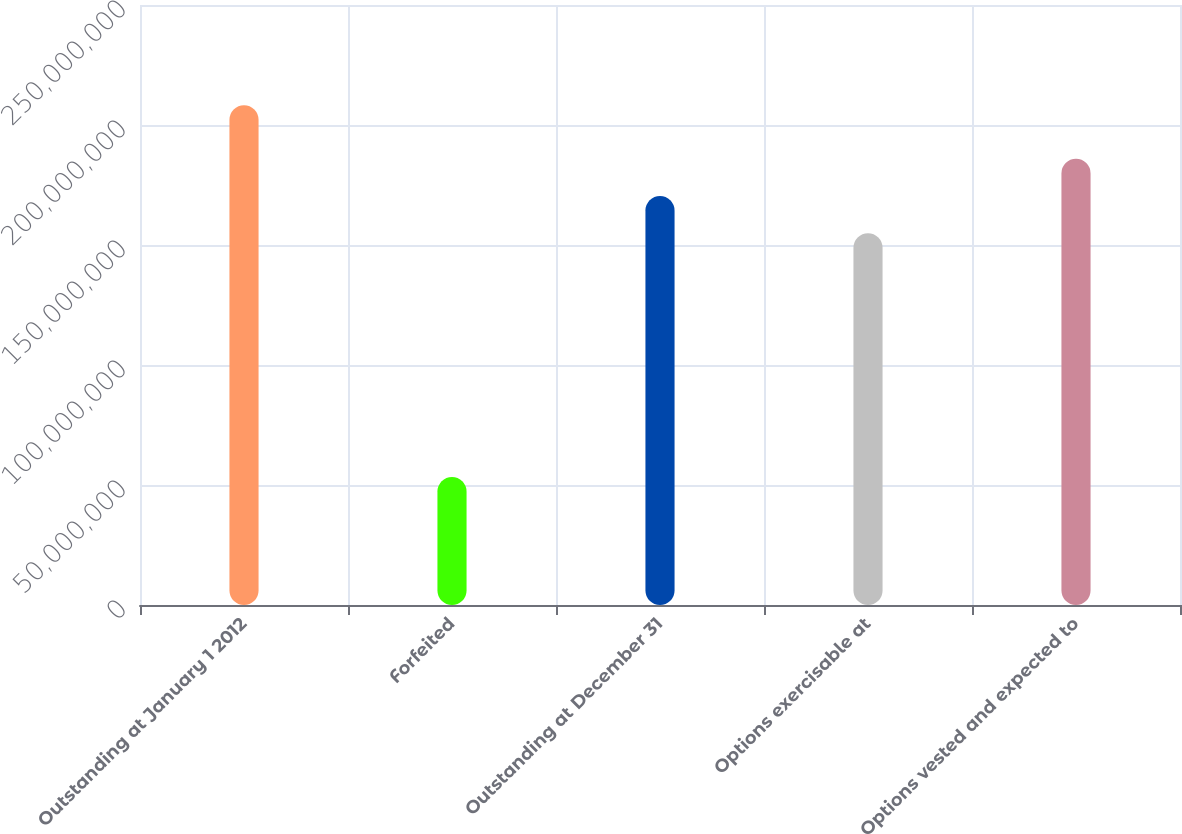<chart> <loc_0><loc_0><loc_500><loc_500><bar_chart><fcel>Outstanding at January 1 2012<fcel>Forfeited<fcel>Outstanding at December 31<fcel>Options exercisable at<fcel>Options vested and expected to<nl><fcel>2.0827e+08<fcel>5.33459e+07<fcel>1.70415e+08<fcel>1.54923e+08<fcel>1.85907e+08<nl></chart> 